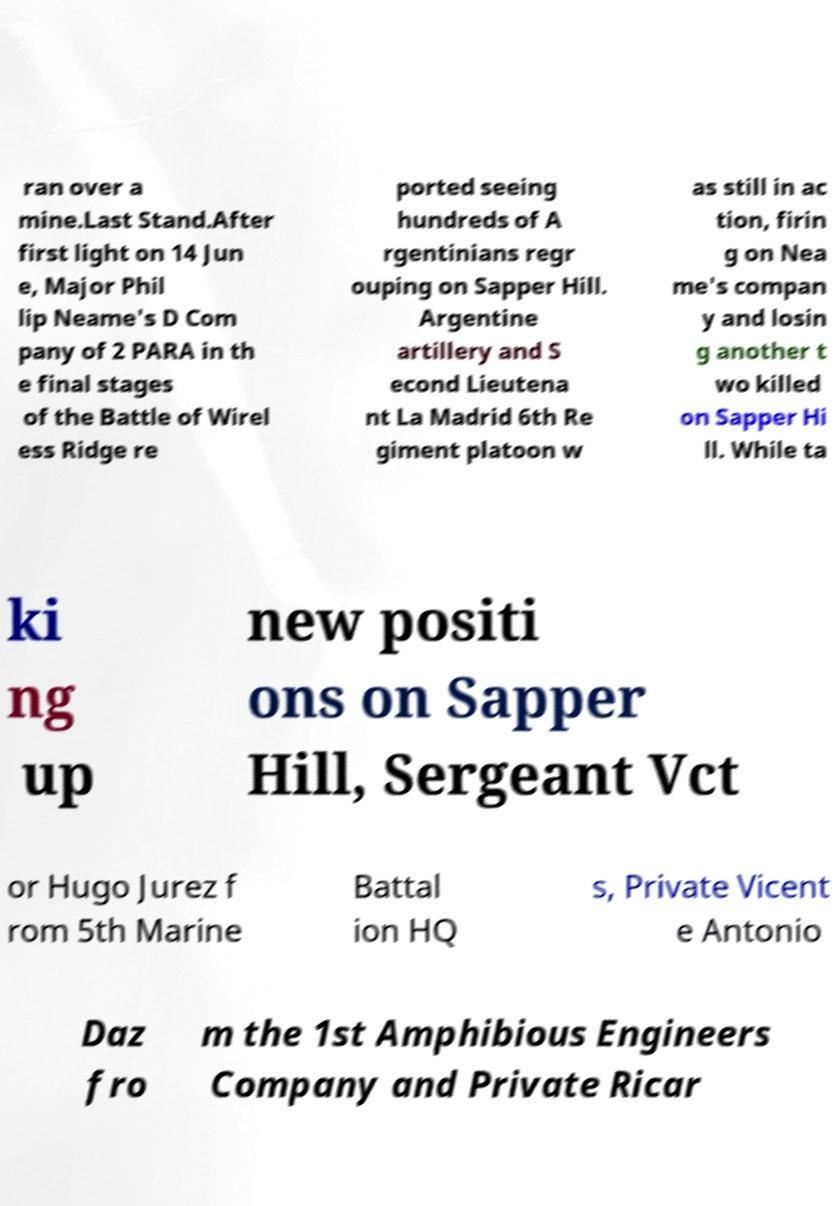Please read and relay the text visible in this image. What does it say? ran over a mine.Last Stand.After first light on 14 Jun e, Major Phil lip Neame's D Com pany of 2 PARA in th e final stages of the Battle of Wirel ess Ridge re ported seeing hundreds of A rgentinians regr ouping on Sapper Hill. Argentine artillery and S econd Lieutena nt La Madrid 6th Re giment platoon w as still in ac tion, firin g on Nea me's compan y and losin g another t wo killed on Sapper Hi ll. While ta ki ng up new positi ons on Sapper Hill, Sergeant Vct or Hugo Jurez f rom 5th Marine Battal ion HQ s, Private Vicent e Antonio Daz fro m the 1st Amphibious Engineers Company and Private Ricar 